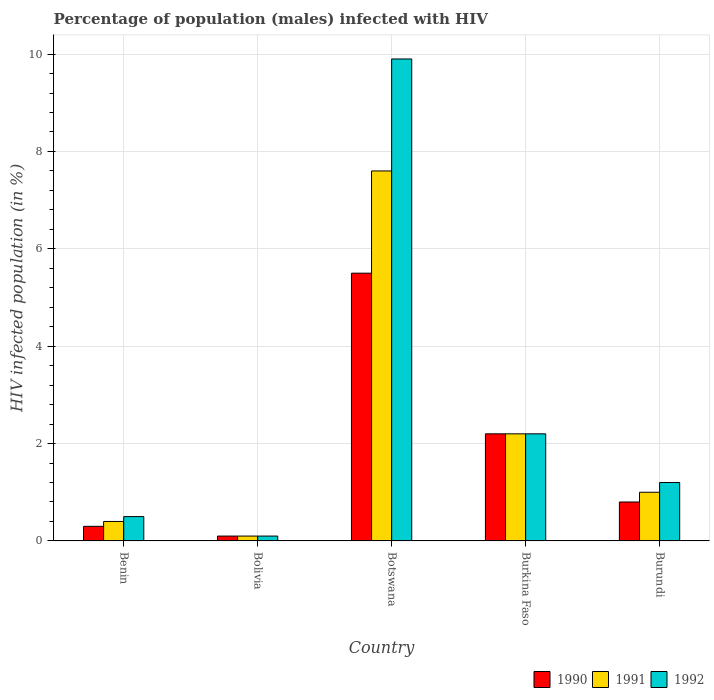How many different coloured bars are there?
Your response must be concise. 3. Are the number of bars per tick equal to the number of legend labels?
Your answer should be compact. Yes. How many bars are there on the 2nd tick from the left?
Keep it short and to the point. 3. What is the label of the 1st group of bars from the left?
Your answer should be compact. Benin. Across all countries, what is the maximum percentage of HIV infected male population in 1990?
Offer a very short reply. 5.5. Across all countries, what is the minimum percentage of HIV infected male population in 1992?
Provide a short and direct response. 0.1. In which country was the percentage of HIV infected male population in 1991 maximum?
Keep it short and to the point. Botswana. In which country was the percentage of HIV infected male population in 1992 minimum?
Your response must be concise. Bolivia. What is the average percentage of HIV infected male population in 1991 per country?
Give a very brief answer. 2.26. What is the difference between the percentage of HIV infected male population of/in 1990 and percentage of HIV infected male population of/in 1991 in Botswana?
Make the answer very short. -2.1. What is the ratio of the percentage of HIV infected male population in 1990 in Benin to that in Burundi?
Provide a short and direct response. 0.37. Is the percentage of HIV infected male population in 1990 in Burkina Faso less than that in Burundi?
Ensure brevity in your answer.  No. Is the difference between the percentage of HIV infected male population in 1990 in Bolivia and Burundi greater than the difference between the percentage of HIV infected male population in 1991 in Bolivia and Burundi?
Provide a succinct answer. Yes. What is the difference between the highest and the second highest percentage of HIV infected male population in 1990?
Your answer should be compact. -1.4. Is the sum of the percentage of HIV infected male population in 1992 in Bolivia and Burundi greater than the maximum percentage of HIV infected male population in 1991 across all countries?
Your response must be concise. No. What does the 3rd bar from the left in Botswana represents?
Offer a very short reply. 1992. Is it the case that in every country, the sum of the percentage of HIV infected male population in 1992 and percentage of HIV infected male population in 1990 is greater than the percentage of HIV infected male population in 1991?
Offer a terse response. Yes. How many bars are there?
Your answer should be very brief. 15. Are all the bars in the graph horizontal?
Make the answer very short. No. What is the difference between two consecutive major ticks on the Y-axis?
Offer a very short reply. 2. Does the graph contain any zero values?
Your response must be concise. No. How many legend labels are there?
Your answer should be compact. 3. What is the title of the graph?
Keep it short and to the point. Percentage of population (males) infected with HIV. What is the label or title of the X-axis?
Ensure brevity in your answer.  Country. What is the label or title of the Y-axis?
Provide a succinct answer. HIV infected population (in %). What is the HIV infected population (in %) of 1991 in Benin?
Offer a terse response. 0.4. What is the HIV infected population (in %) in 1992 in Benin?
Your answer should be very brief. 0.5. What is the HIV infected population (in %) in 1990 in Botswana?
Provide a succinct answer. 5.5. What is the HIV infected population (in %) of 1991 in Botswana?
Make the answer very short. 7.6. What is the HIV infected population (in %) in 1992 in Botswana?
Provide a succinct answer. 9.9. What is the HIV infected population (in %) in 1990 in Burkina Faso?
Offer a terse response. 2.2. What is the HIV infected population (in %) of 1991 in Burundi?
Give a very brief answer. 1. What is the HIV infected population (in %) of 1992 in Burundi?
Keep it short and to the point. 1.2. Across all countries, what is the maximum HIV infected population (in %) in 1991?
Offer a terse response. 7.6. Across all countries, what is the maximum HIV infected population (in %) in 1992?
Ensure brevity in your answer.  9.9. Across all countries, what is the minimum HIV infected population (in %) in 1990?
Keep it short and to the point. 0.1. Across all countries, what is the minimum HIV infected population (in %) in 1991?
Offer a terse response. 0.1. What is the total HIV infected population (in %) of 1990 in the graph?
Your answer should be very brief. 8.9. What is the difference between the HIV infected population (in %) of 1990 in Benin and that in Bolivia?
Offer a terse response. 0.2. What is the difference between the HIV infected population (in %) of 1990 in Benin and that in Botswana?
Offer a terse response. -5.2. What is the difference between the HIV infected population (in %) of 1990 in Benin and that in Burkina Faso?
Your response must be concise. -1.9. What is the difference between the HIV infected population (in %) in 1992 in Benin and that in Burkina Faso?
Provide a succinct answer. -1.7. What is the difference between the HIV infected population (in %) of 1992 in Benin and that in Burundi?
Keep it short and to the point. -0.7. What is the difference between the HIV infected population (in %) of 1991 in Bolivia and that in Burkina Faso?
Ensure brevity in your answer.  -2.1. What is the difference between the HIV infected population (in %) of 1992 in Bolivia and that in Burundi?
Make the answer very short. -1.1. What is the difference between the HIV infected population (in %) of 1990 in Benin and the HIV infected population (in %) of 1991 in Bolivia?
Keep it short and to the point. 0.2. What is the difference between the HIV infected population (in %) of 1990 in Benin and the HIV infected population (in %) of 1991 in Botswana?
Your answer should be very brief. -7.3. What is the difference between the HIV infected population (in %) of 1990 in Benin and the HIV infected population (in %) of 1992 in Botswana?
Provide a succinct answer. -9.6. What is the difference between the HIV infected population (in %) in 1991 in Benin and the HIV infected population (in %) in 1992 in Botswana?
Your answer should be very brief. -9.5. What is the difference between the HIV infected population (in %) in 1990 in Benin and the HIV infected population (in %) in 1991 in Burkina Faso?
Keep it short and to the point. -1.9. What is the difference between the HIV infected population (in %) of 1991 in Benin and the HIV infected population (in %) of 1992 in Burkina Faso?
Ensure brevity in your answer.  -1.8. What is the difference between the HIV infected population (in %) of 1990 in Benin and the HIV infected population (in %) of 1992 in Burundi?
Your answer should be very brief. -0.9. What is the difference between the HIV infected population (in %) of 1990 in Bolivia and the HIV infected population (in %) of 1991 in Botswana?
Keep it short and to the point. -7.5. What is the difference between the HIV infected population (in %) in 1990 in Bolivia and the HIV infected population (in %) in 1992 in Botswana?
Offer a terse response. -9.8. What is the difference between the HIV infected population (in %) in 1991 in Bolivia and the HIV infected population (in %) in 1992 in Botswana?
Provide a succinct answer. -9.8. What is the difference between the HIV infected population (in %) of 1990 in Bolivia and the HIV infected population (in %) of 1992 in Burkina Faso?
Ensure brevity in your answer.  -2.1. What is the difference between the HIV infected population (in %) in 1990 in Botswana and the HIV infected population (in %) in 1991 in Burkina Faso?
Keep it short and to the point. 3.3. What is the difference between the HIV infected population (in %) of 1990 in Botswana and the HIV infected population (in %) of 1992 in Burkina Faso?
Your answer should be very brief. 3.3. What is the difference between the HIV infected population (in %) in 1991 in Botswana and the HIV infected population (in %) in 1992 in Burkina Faso?
Provide a succinct answer. 5.4. What is the difference between the HIV infected population (in %) in 1990 in Botswana and the HIV infected population (in %) in 1991 in Burundi?
Your answer should be compact. 4.5. What is the difference between the HIV infected population (in %) in 1990 in Botswana and the HIV infected population (in %) in 1992 in Burundi?
Provide a succinct answer. 4.3. What is the difference between the HIV infected population (in %) in 1991 in Botswana and the HIV infected population (in %) in 1992 in Burundi?
Make the answer very short. 6.4. What is the average HIV infected population (in %) in 1990 per country?
Your answer should be very brief. 1.78. What is the average HIV infected population (in %) in 1991 per country?
Your answer should be very brief. 2.26. What is the average HIV infected population (in %) in 1992 per country?
Offer a terse response. 2.78. What is the difference between the HIV infected population (in %) in 1990 and HIV infected population (in %) in 1992 in Benin?
Keep it short and to the point. -0.2. What is the difference between the HIV infected population (in %) in 1991 and HIV infected population (in %) in 1992 in Benin?
Your response must be concise. -0.1. What is the difference between the HIV infected population (in %) of 1991 and HIV infected population (in %) of 1992 in Bolivia?
Your answer should be very brief. 0. What is the difference between the HIV infected population (in %) of 1990 and HIV infected population (in %) of 1991 in Botswana?
Provide a succinct answer. -2.1. What is the difference between the HIV infected population (in %) in 1991 and HIV infected population (in %) in 1992 in Botswana?
Your answer should be compact. -2.3. What is the difference between the HIV infected population (in %) of 1990 and HIV infected population (in %) of 1991 in Burkina Faso?
Offer a terse response. 0. What is the difference between the HIV infected population (in %) of 1990 and HIV infected population (in %) of 1992 in Burkina Faso?
Offer a very short reply. 0. What is the difference between the HIV infected population (in %) in 1990 and HIV infected population (in %) in 1991 in Burundi?
Keep it short and to the point. -0.2. What is the difference between the HIV infected population (in %) in 1990 and HIV infected population (in %) in 1992 in Burundi?
Provide a succinct answer. -0.4. What is the difference between the HIV infected population (in %) in 1991 and HIV infected population (in %) in 1992 in Burundi?
Your response must be concise. -0.2. What is the ratio of the HIV infected population (in %) in 1990 in Benin to that in Botswana?
Your answer should be very brief. 0.05. What is the ratio of the HIV infected population (in %) in 1991 in Benin to that in Botswana?
Offer a very short reply. 0.05. What is the ratio of the HIV infected population (in %) of 1992 in Benin to that in Botswana?
Offer a very short reply. 0.05. What is the ratio of the HIV infected population (in %) in 1990 in Benin to that in Burkina Faso?
Your answer should be compact. 0.14. What is the ratio of the HIV infected population (in %) of 1991 in Benin to that in Burkina Faso?
Offer a terse response. 0.18. What is the ratio of the HIV infected population (in %) of 1992 in Benin to that in Burkina Faso?
Your response must be concise. 0.23. What is the ratio of the HIV infected population (in %) in 1990 in Benin to that in Burundi?
Keep it short and to the point. 0.38. What is the ratio of the HIV infected population (in %) in 1991 in Benin to that in Burundi?
Keep it short and to the point. 0.4. What is the ratio of the HIV infected population (in %) in 1992 in Benin to that in Burundi?
Keep it short and to the point. 0.42. What is the ratio of the HIV infected population (in %) of 1990 in Bolivia to that in Botswana?
Provide a succinct answer. 0.02. What is the ratio of the HIV infected population (in %) in 1991 in Bolivia to that in Botswana?
Your answer should be compact. 0.01. What is the ratio of the HIV infected population (in %) of 1992 in Bolivia to that in Botswana?
Offer a very short reply. 0.01. What is the ratio of the HIV infected population (in %) of 1990 in Bolivia to that in Burkina Faso?
Your answer should be very brief. 0.05. What is the ratio of the HIV infected population (in %) of 1991 in Bolivia to that in Burkina Faso?
Your answer should be compact. 0.05. What is the ratio of the HIV infected population (in %) in 1992 in Bolivia to that in Burkina Faso?
Offer a very short reply. 0.05. What is the ratio of the HIV infected population (in %) of 1991 in Bolivia to that in Burundi?
Offer a terse response. 0.1. What is the ratio of the HIV infected population (in %) of 1992 in Bolivia to that in Burundi?
Your answer should be compact. 0.08. What is the ratio of the HIV infected population (in %) in 1990 in Botswana to that in Burkina Faso?
Offer a very short reply. 2.5. What is the ratio of the HIV infected population (in %) in 1991 in Botswana to that in Burkina Faso?
Provide a short and direct response. 3.45. What is the ratio of the HIV infected population (in %) in 1990 in Botswana to that in Burundi?
Your answer should be very brief. 6.88. What is the ratio of the HIV infected population (in %) of 1992 in Botswana to that in Burundi?
Your response must be concise. 8.25. What is the ratio of the HIV infected population (in %) in 1990 in Burkina Faso to that in Burundi?
Make the answer very short. 2.75. What is the ratio of the HIV infected population (in %) in 1992 in Burkina Faso to that in Burundi?
Keep it short and to the point. 1.83. What is the difference between the highest and the second highest HIV infected population (in %) of 1990?
Offer a very short reply. 3.3. What is the difference between the highest and the second highest HIV infected population (in %) of 1991?
Your response must be concise. 5.4. What is the difference between the highest and the second highest HIV infected population (in %) in 1992?
Your answer should be compact. 7.7. What is the difference between the highest and the lowest HIV infected population (in %) of 1990?
Provide a short and direct response. 5.4. What is the difference between the highest and the lowest HIV infected population (in %) of 1992?
Ensure brevity in your answer.  9.8. 